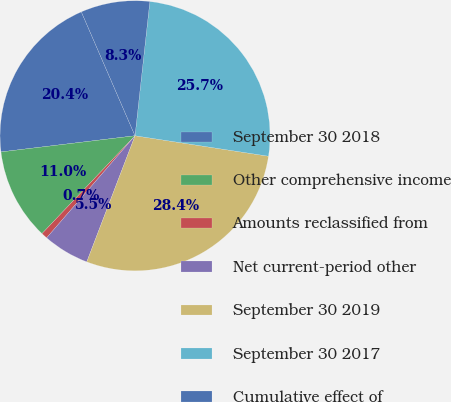<chart> <loc_0><loc_0><loc_500><loc_500><pie_chart><fcel>September 30 2018<fcel>Other comprehensive income<fcel>Amounts reclassified from<fcel>Net current-period other<fcel>September 30 2019<fcel>September 30 2017<fcel>Cumulative effect of<nl><fcel>20.4%<fcel>10.99%<fcel>0.74%<fcel>5.54%<fcel>28.39%<fcel>25.67%<fcel>8.26%<nl></chart> 